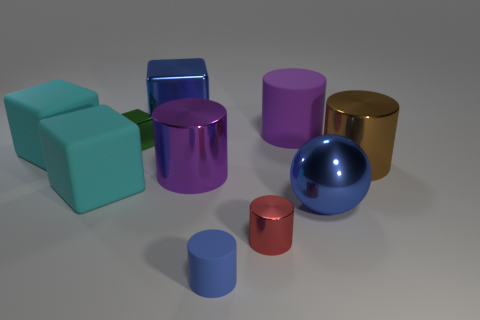How many other objects are the same material as the small blue object?
Offer a very short reply. 3. There is a blue metal thing left of the tiny blue object; is it the same shape as the small red object?
Keep it short and to the point. No. How many large objects are red cylinders or cylinders?
Offer a terse response. 3. Is the number of blue metal objects to the right of the ball the same as the number of small blue cylinders to the left of the big shiny cube?
Provide a short and direct response. Yes. How many other objects are the same color as the tiny matte cylinder?
Your answer should be very brief. 2. Is the color of the shiny ball the same as the small cylinder that is in front of the small shiny cylinder?
Make the answer very short. Yes. What number of red objects are either tiny matte things or matte blocks?
Your response must be concise. 0. Is the number of tiny green blocks to the right of the blue rubber thing the same as the number of large cyan balls?
Offer a terse response. Yes. There is another small thing that is the same shape as the blue rubber thing; what color is it?
Your response must be concise. Red. What number of large brown things are the same shape as the red thing?
Provide a succinct answer. 1. 